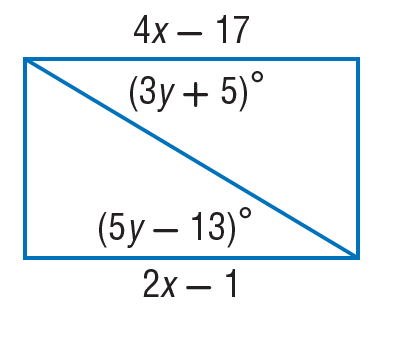Answer the mathemtical geometry problem and directly provide the correct option letter.
Question: Find y so that the quadrilateral is a parallelogram.
Choices: A: 9 B: 13 C: 18 D: 19 A 